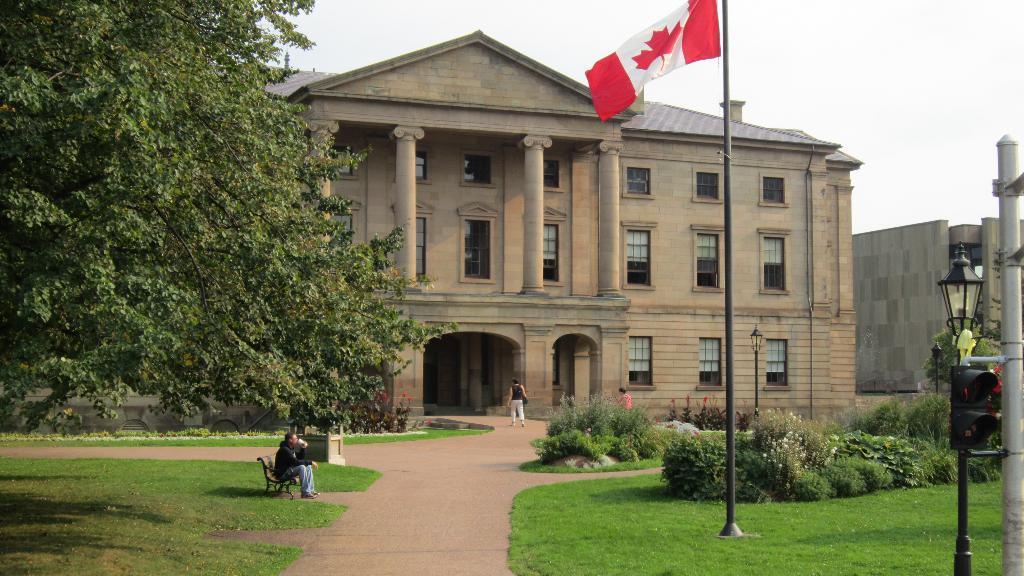Describe this image in one or two sentences. In this picture we can see three people on the ground and one person is sitting on a bench, here we can see a flag, traffic signal and a pole with a light and in the background we can see buildings, trees and the sky. 